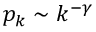<formula> <loc_0><loc_0><loc_500><loc_500>p _ { k } \sim k ^ { - \gamma }</formula> 